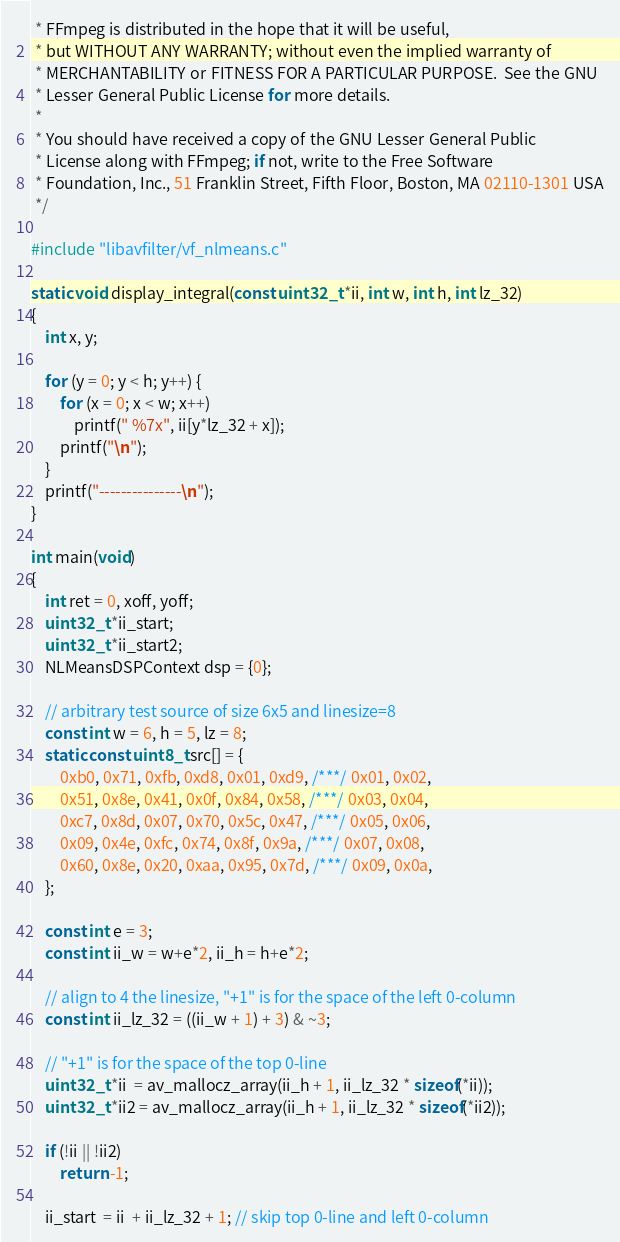<code> <loc_0><loc_0><loc_500><loc_500><_C_> * FFmpeg is distributed in the hope that it will be useful,
 * but WITHOUT ANY WARRANTY; without even the implied warranty of
 * MERCHANTABILITY or FITNESS FOR A PARTICULAR PURPOSE.  See the GNU
 * Lesser General Public License for more details.
 *
 * You should have received a copy of the GNU Lesser General Public
 * License along with FFmpeg; if not, write to the Free Software
 * Foundation, Inc., 51 Franklin Street, Fifth Floor, Boston, MA 02110-1301 USA
 */

#include "libavfilter/vf_nlmeans.c"

static void display_integral(const uint32_t *ii, int w, int h, int lz_32)
{
    int x, y;

    for (y = 0; y < h; y++) {
        for (x = 0; x < w; x++)
            printf(" %7x", ii[y*lz_32 + x]);
        printf("\n");
    }
    printf("---------------\n");
}

int main(void)
{
    int ret = 0, xoff, yoff;
    uint32_t *ii_start;
    uint32_t *ii_start2;
    NLMeansDSPContext dsp = {0};

    // arbitrary test source of size 6x5 and linesize=8
    const int w = 6, h = 5, lz = 8;
    static const uint8_t src[] = {
        0xb0, 0x71, 0xfb, 0xd8, 0x01, 0xd9, /***/ 0x01, 0x02,
        0x51, 0x8e, 0x41, 0x0f, 0x84, 0x58, /***/ 0x03, 0x04,
        0xc7, 0x8d, 0x07, 0x70, 0x5c, 0x47, /***/ 0x05, 0x06,
        0x09, 0x4e, 0xfc, 0x74, 0x8f, 0x9a, /***/ 0x07, 0x08,
        0x60, 0x8e, 0x20, 0xaa, 0x95, 0x7d, /***/ 0x09, 0x0a,
    };

    const int e = 3;
    const int ii_w = w+e*2, ii_h = h+e*2;

    // align to 4 the linesize, "+1" is for the space of the left 0-column
    const int ii_lz_32 = ((ii_w + 1) + 3) & ~3;

    // "+1" is for the space of the top 0-line
    uint32_t *ii  = av_mallocz_array(ii_h + 1, ii_lz_32 * sizeof(*ii));
    uint32_t *ii2 = av_mallocz_array(ii_h + 1, ii_lz_32 * sizeof(*ii2));

    if (!ii || !ii2)
        return -1;

    ii_start  = ii  + ii_lz_32 + 1; // skip top 0-line and left 0-column</code> 